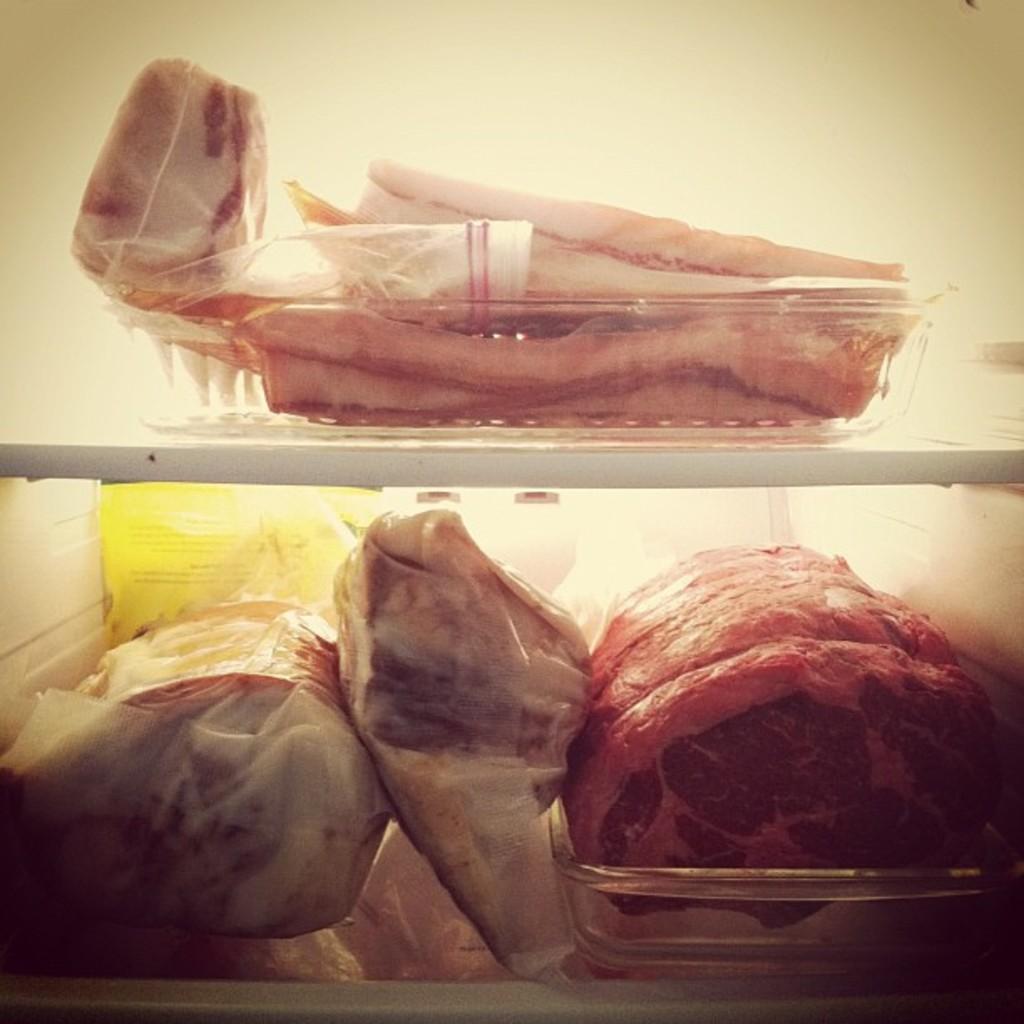Could you give a brief overview of what you see in this image? In the foreground of this image, there are meat in the baskets which are kept in the shelves and we can also see few objects. 